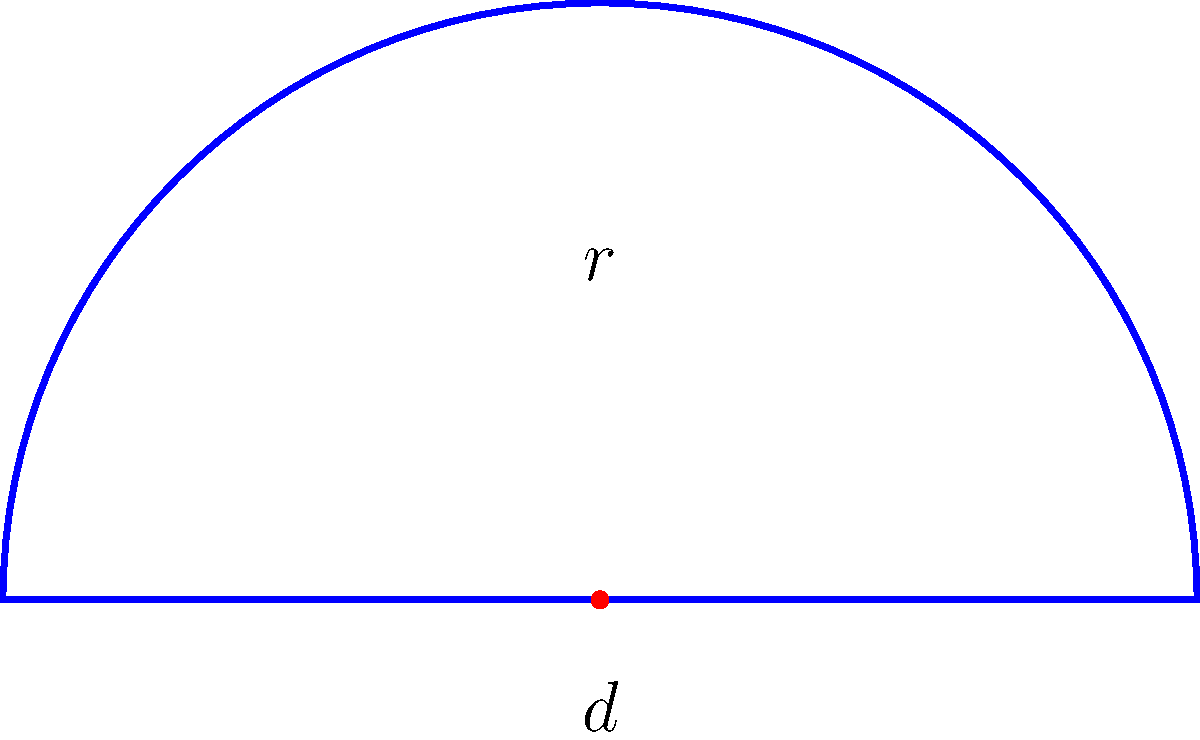As an aspiring art historian, you're studying the architecture of ancient Greek amphitheaters. You come across a perfectly semicircular amphitheater with a diameter of 100 meters. Calculate the perimeter of this amphitheater, considering both the curved part and the straight base. Round your answer to the nearest meter. Let's approach this step-by-step:

1) The amphitheater is a semicircle. Its perimeter consists of two parts:
   a) The curved part (semicircumference)
   b) The straight base (diameter)

2) For the curved part:
   - The formula for the circumference of a full circle is $C = 2\pi r$
   - For a semicircle, we use half of this: $\frac{1}{2}(2\pi r) = \pi r$
   - The diameter is 100 m, so the radius $r = 50$ m
   - Semicircumference $= \pi r = \pi(50) = 50\pi$ meters

3) For the straight base:
   - This is simply the diameter, which is 100 meters

4) Total perimeter:
   Perimeter $= Semicircumference + Diameter$
              $= 50\pi + 100$ meters

5) Calculate and round to the nearest meter:
   $50\pi + 100 \approx 157.08 + 100 = 257.08$ meters
   Rounded to the nearest meter: 257 meters
Answer: 257 meters 